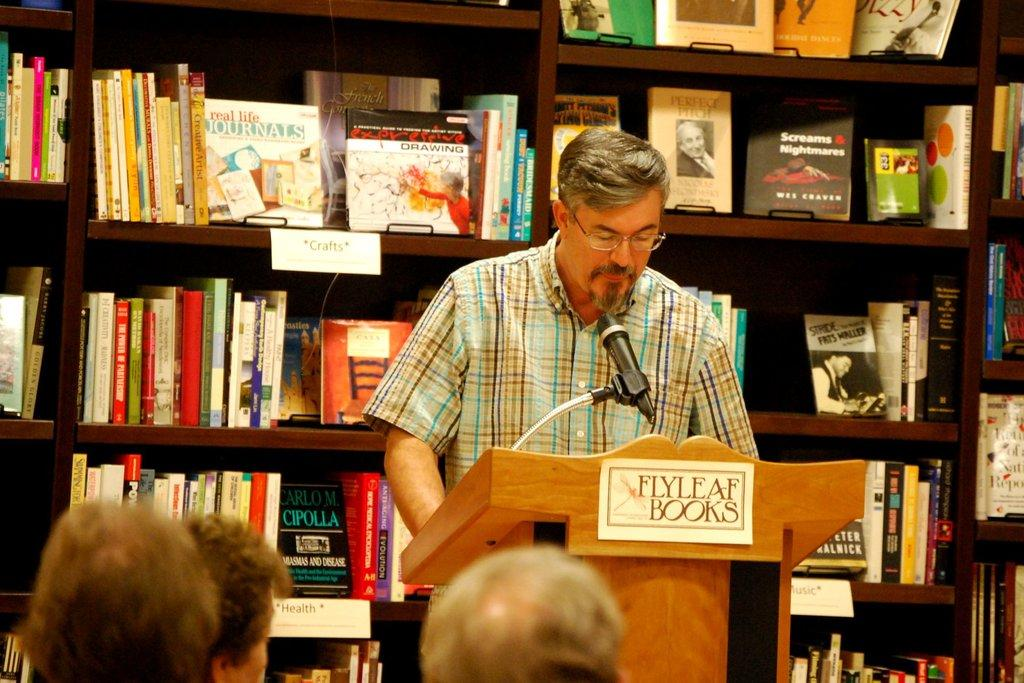<image>
Offer a succinct explanation of the picture presented. A man stands at a podium in the Flyleaf Books bookstore speaking to a group of people. 